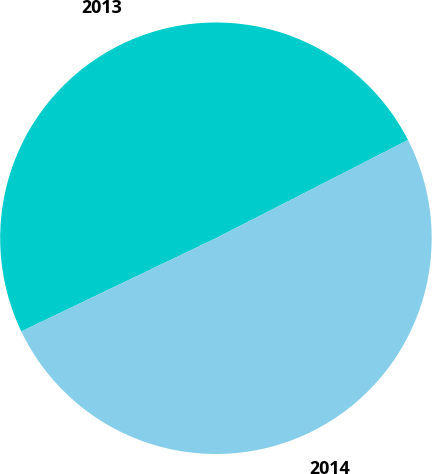<chart> <loc_0><loc_0><loc_500><loc_500><pie_chart><fcel>2013<fcel>2014<nl><fcel>49.59%<fcel>50.41%<nl></chart> 